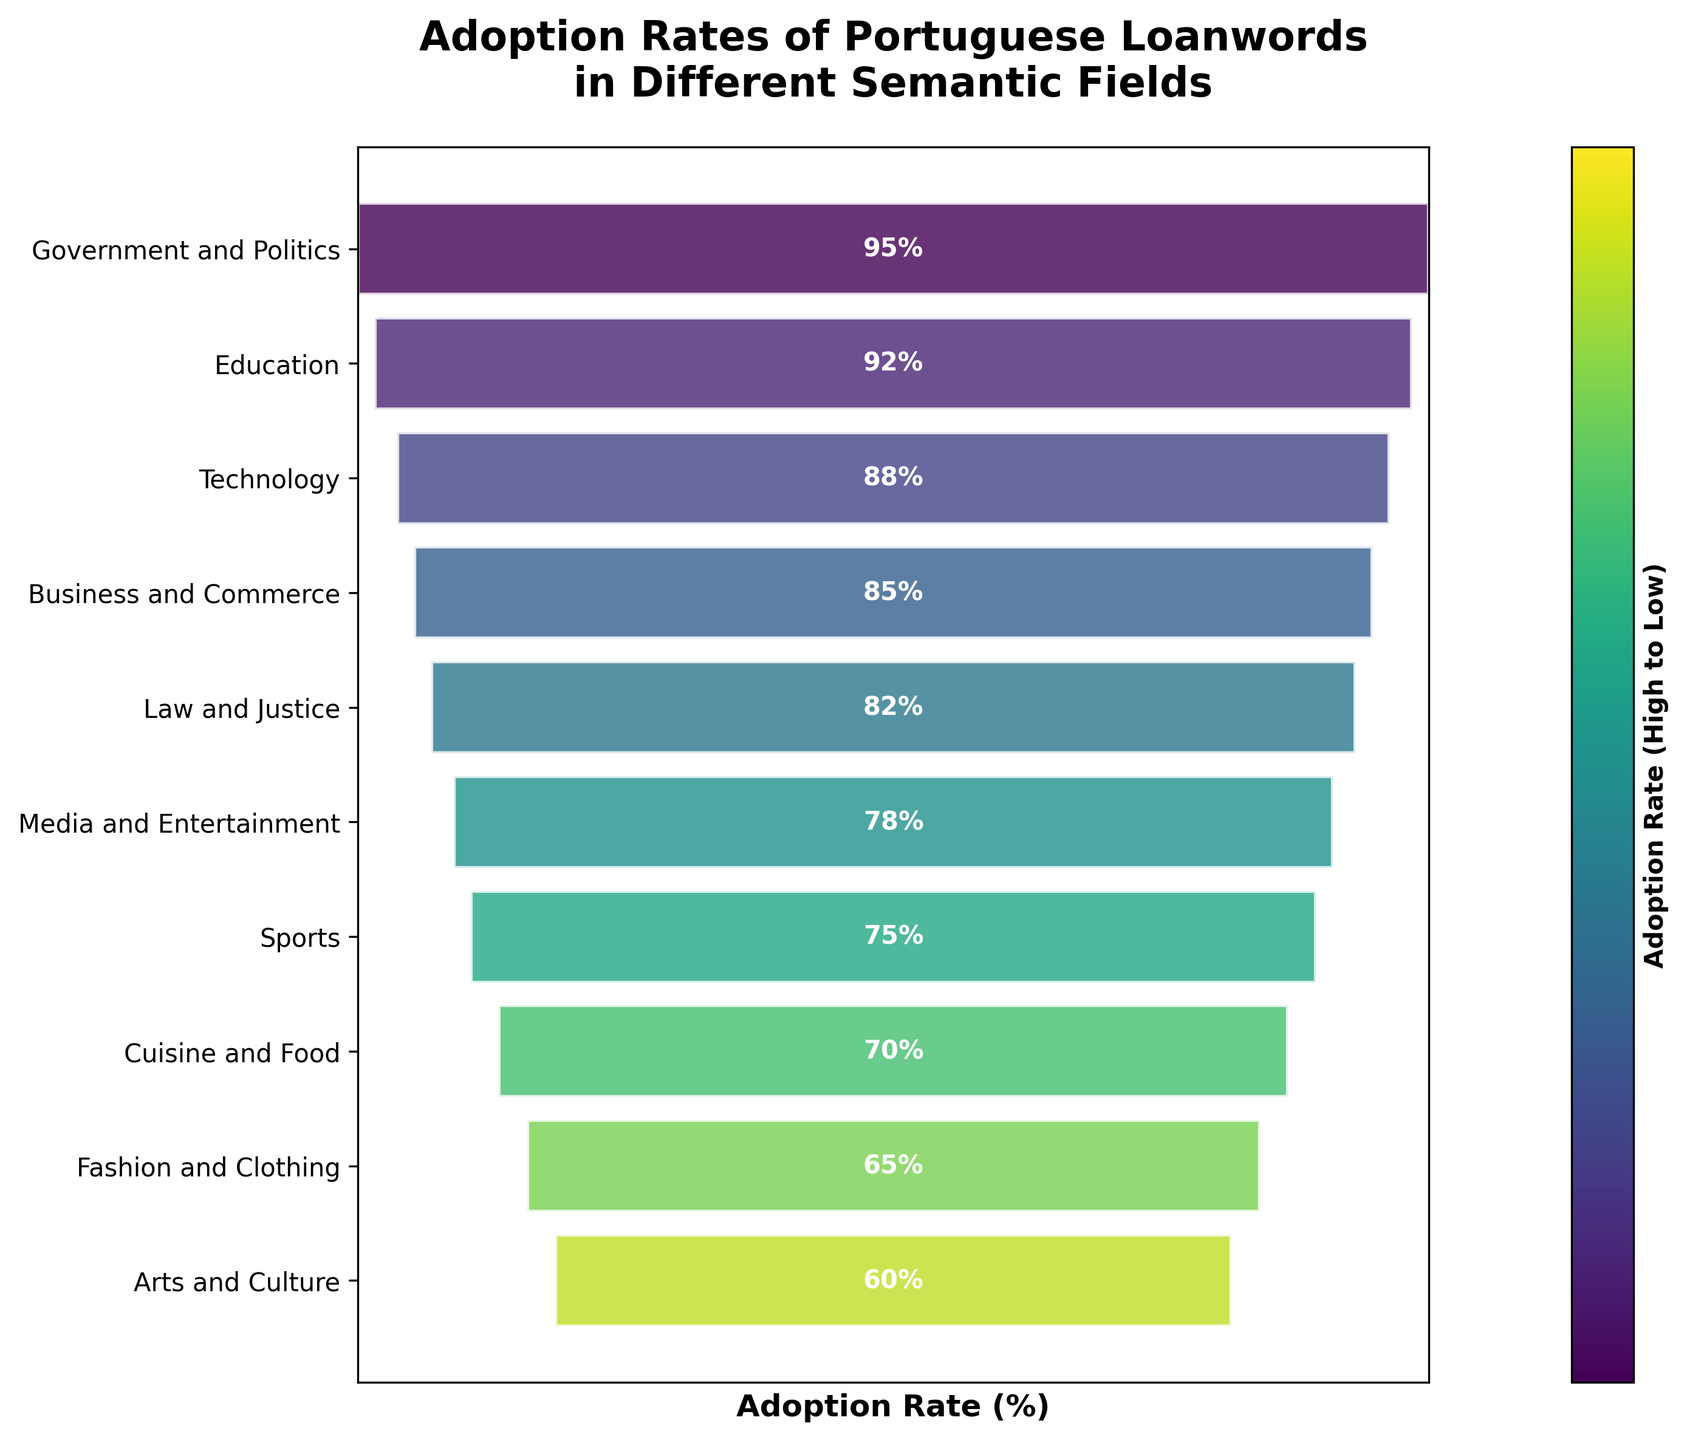What is the adoption rate in the Technology field? To find the adoption rate of the Technology field, look for the corresponding segment in the funnel chart and read the label on it.
Answer: 88% Which semantic field has the highest adoption rate? Identify the topmost segment of the funnel chart which indicates the highest adoption rate.
Answer: Government and Politics What is the lowest adoption rate in the funnel chart? Locate the bottom segment of the funnel chart, which represents the lowest adoption rate.
Answer: 60% How many semantic fields have an adoption rate above 80%? Count the number of segments in the funnel chart whose labels display adoption rates higher than 80%.
Answer: 5 Compare the adoption rates of Technology and Cuisine and Food fields. Which one is higher and by how much? Find the adoption rates of Technology (88%) and Cuisine and Food (70%) from the chart and subtract the smaller value from the larger one.
Answer: Technology is higher by 18% What is the total number of semantic fields represented in the chart? Count all the segments in the funnel chart.
Answer: 10 What is the difference in adoption rate between the highest and lowest fields? Subtract the adoption rate of the bottom segment (60%) from the top segment (95%).
Answer: 35% On average, what is the adoption rate for semantic fields listed in the funnel chart? Sum up all the adoption rates of the 10 semantic fields and divide by the number of fields. (95 + 92+ 88 + 85 + 82 + 78 + 75 + 70 + 65 + 60)/10 = 79
Answer: 79% Which semantic field is immediately above Sports in terms of adoption rate? Look for the segment labeled as Sports and identify the segment directly above it.
Answer: Media and Entertainment What is the range of adoption rates represented in this funnel chart? Determine the difference between the maximum and minimum adoption rates in the chart: 95% - 60% = 35%
Answer: 35% 